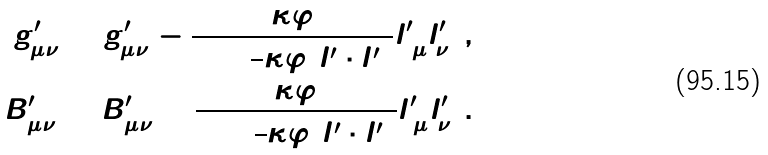Convert formula to latex. <formula><loc_0><loc_0><loc_500><loc_500>g ^ { \prime } _ { \mu \nu } = \tilde { g } ^ { \prime } _ { \mu \nu } - \frac { \kappa \varphi } { 1 + \frac { 1 } { 2 } \kappa \varphi ( l ^ { \prime } \cdot \bar { l } ^ { \prime } ) } l ^ { \prime } _ { ( \mu } \bar { l } ^ { \prime } _ { \nu ) } \, , \\ B ^ { \prime } _ { \mu \nu } = \tilde { B } ^ { \prime } _ { \mu \nu } + \frac { \kappa \varphi } { 1 + \frac { 1 } { 2 } \kappa \varphi ( l ^ { \prime } \cdot \bar { l } ^ { \prime } ) } l ^ { \prime } _ { [ \mu } \bar { l } ^ { \prime } _ { \nu ] } \, .</formula> 